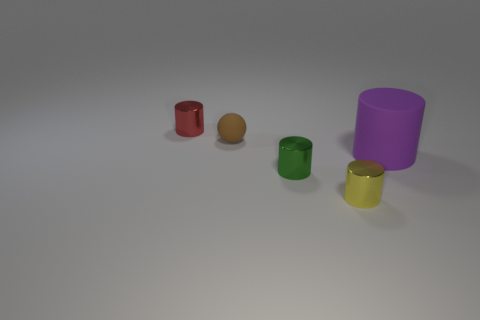Do the green metallic object and the yellow thing have the same shape?
Your response must be concise. Yes. Does the brown matte thing have the same size as the red cylinder on the left side of the big purple cylinder?
Keep it short and to the point. Yes. What number of gray shiny spheres have the same size as the yellow thing?
Offer a terse response. 0. How many large objects are red shiny things or yellow shiny things?
Ensure brevity in your answer.  0. Are any big red things visible?
Give a very brief answer. No. Are there more yellow metallic cylinders that are to the left of the big rubber thing than small shiny cylinders right of the red metallic cylinder?
Ensure brevity in your answer.  No. What color is the rubber thing that is right of the metallic cylinder that is in front of the tiny green metallic thing?
Offer a terse response. Purple. There is a matte object in front of the matte object that is left of the small yellow metal object right of the small brown matte sphere; what is its size?
Keep it short and to the point. Large. What shape is the small green thing?
Keep it short and to the point. Cylinder. There is a metallic cylinder on the left side of the tiny rubber object; what number of metal cylinders are on the right side of it?
Your answer should be very brief. 2. 